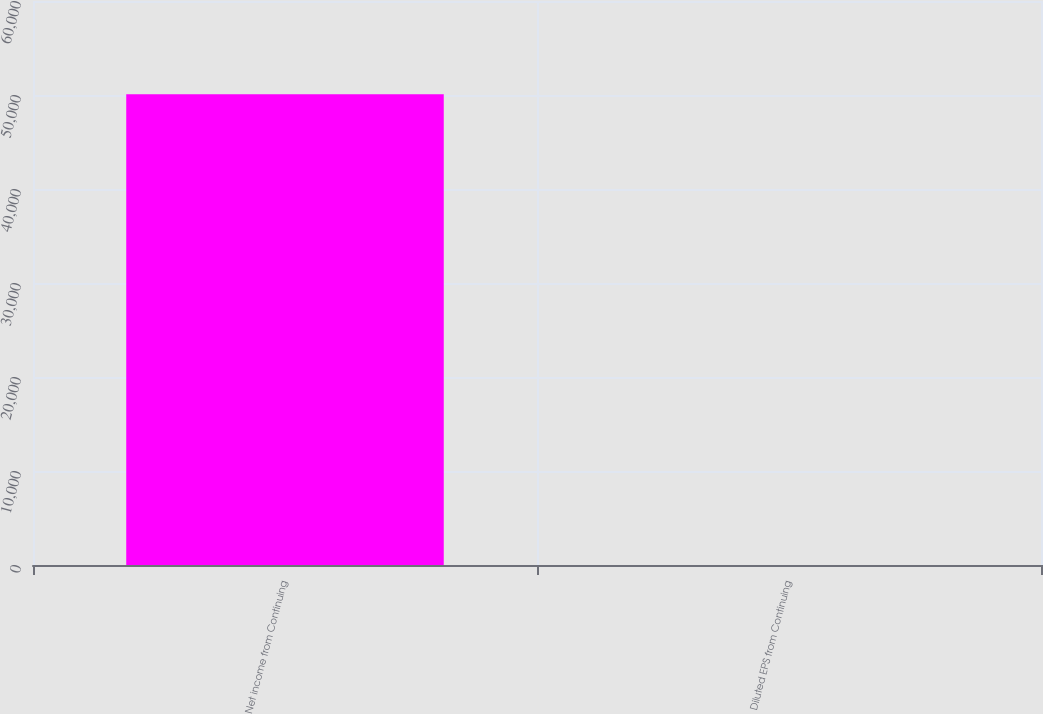<chart> <loc_0><loc_0><loc_500><loc_500><bar_chart><fcel>Net income from Continuing<fcel>Diluted EPS from Continuing<nl><fcel>50070.9<fcel>1.51<nl></chart> 